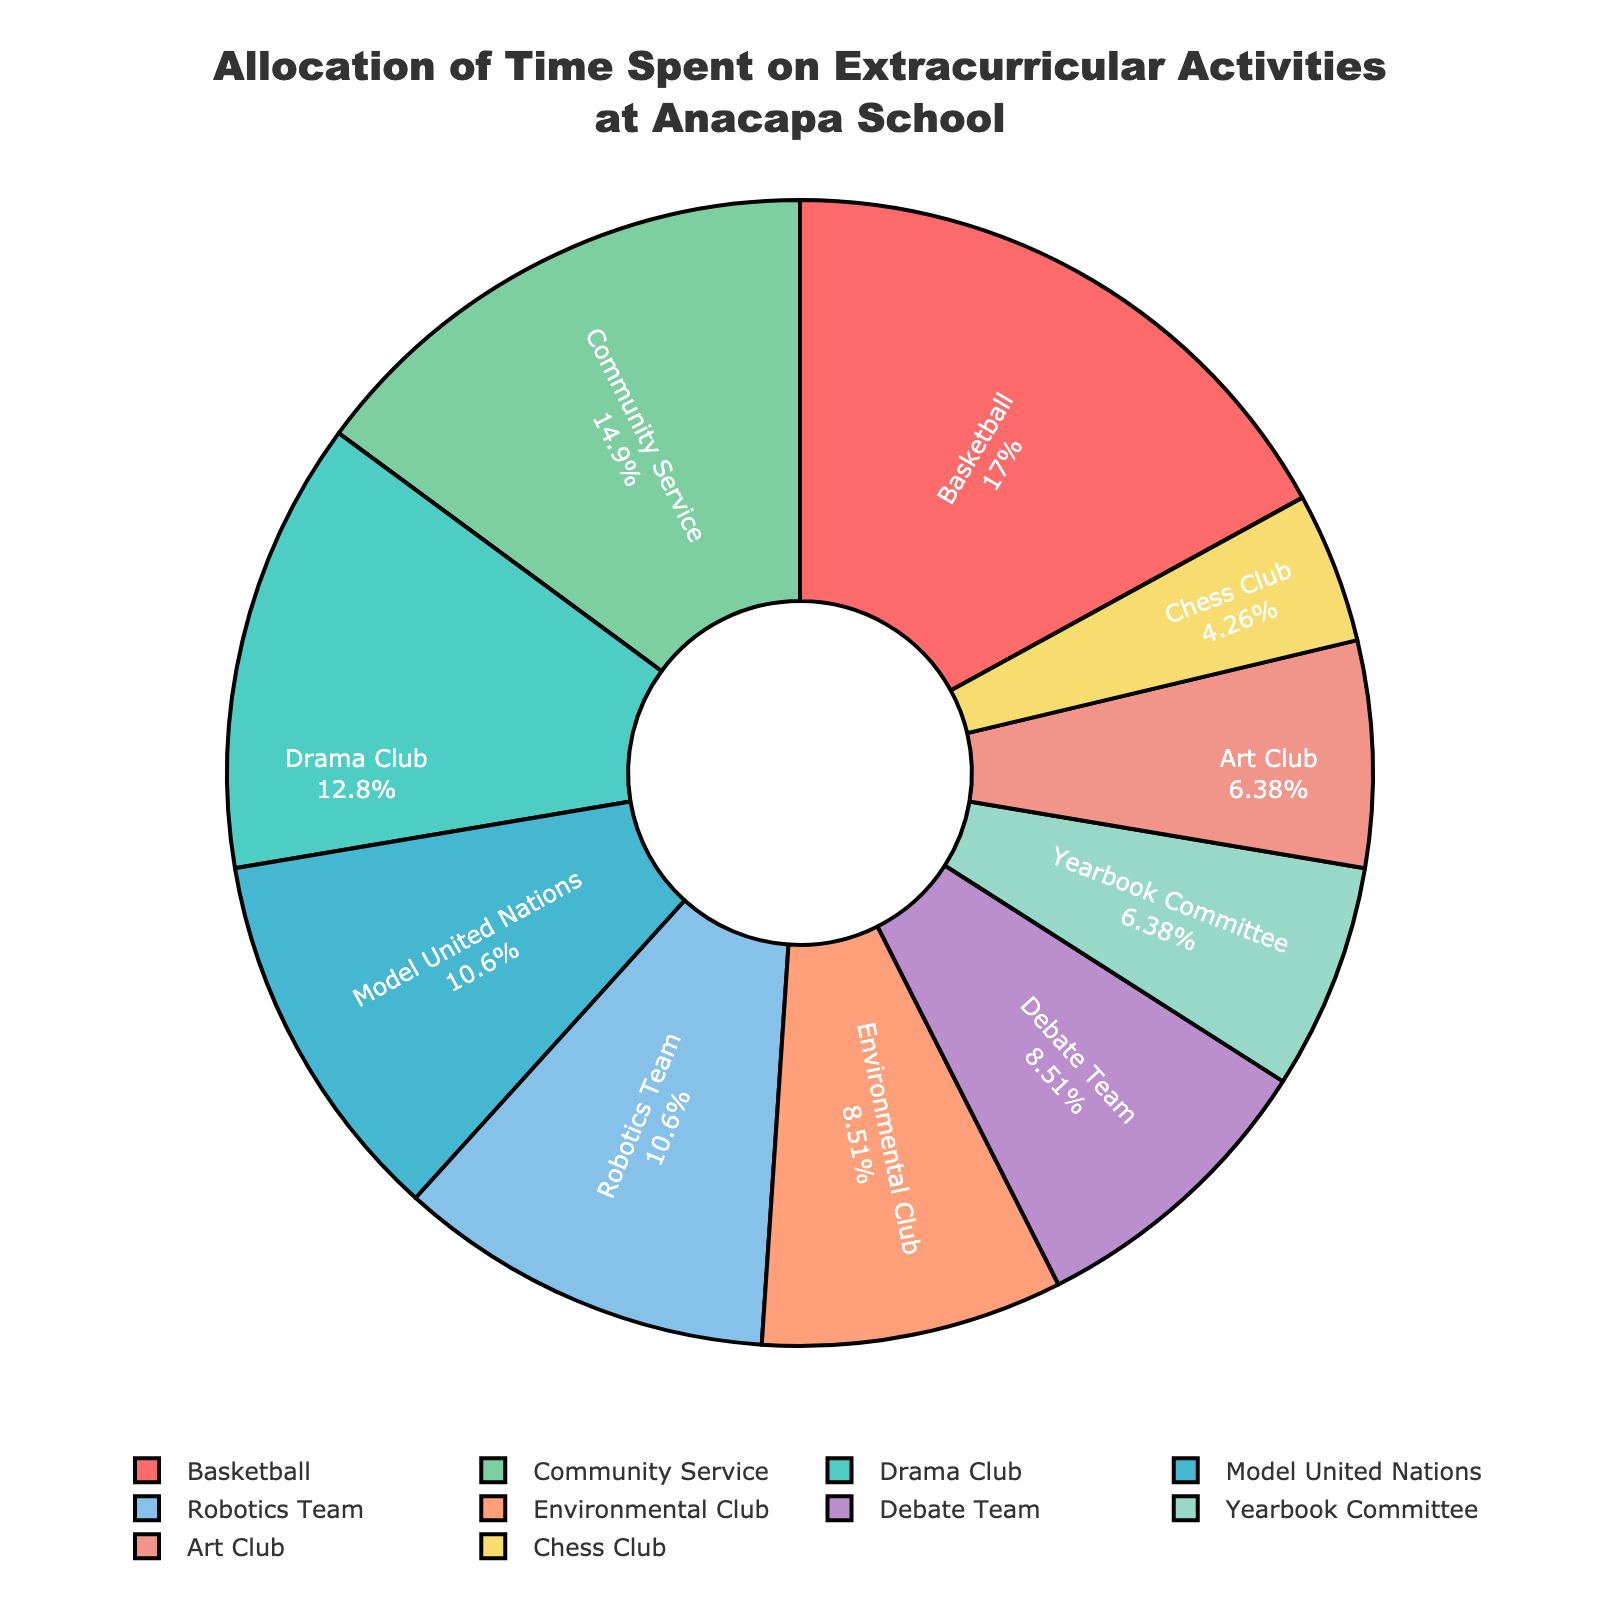What's the activity with the highest number of hours? By looking at the chart, identify the segment with the largest proportion, which corresponds to the activity with the highest number of hours. The basketball segment is the largest, indicating it has the highest number of hours.
Answer: Basketball Which activity has the smallest portion on the pie chart? Locate the segment with the smallest area within the pie chart. The Chess Club segment is the smallest, indicating it has the fewest hours allocated.
Answer: Chess Club How many hours in total are spent on all extracurricular activities? Sum all the hours spent on each activity: 8 (Basketball) + 6 (Drama Club) + 5 (Model United Nations) + 4 (Environmental Club) + 3 (Yearbook Committee) + 2 (Chess Club) + 4 (Debate Team) + 7 (Community Service) + 3 (Art Club) + 5 (Robotics Team) = 47 hours.
Answer: 47 Which activities have an equal amount of hours allocated? Look at the chart and compare segments with equal sizes, which will represent activities with the same amount of hours. Both Environmental Club and Debate Team have equal segments, representing 4 hours each.
Answer: Environmental Club and Debate Team What percentage of the total time is spent on Community Service? Community Service accounts for 7 hours. To find the percentage, use the total time of 47 hours: (7/47) * 100 ≈ 14.89%.
Answer: 14.89% How many hours more are spent on Basketball compared to Chess Club? Subtract the hours spent on Chess Club from the hours spent on Basketball: 8 (Basketball) - 2 (Chess Club) = 6 hours.
Answer: 6 hours Compare the time spent on Drama Club to Art Club. Which is greater and by how many hours? Drama Club has 6 hours, and Art Club has 3 hours. Subtract the smaller value from the larger value: 6 (Drama Club) - 3 (Art Club) = 3 hours more for Drama Club.
Answer: Drama Club, 3 hours What's the average number of hours spent on all the activities? To find the average, divide the total hours by the number of activities: 47 hours / 10 activities = 4.7 hours on average.
Answer: 4.7 hours Which color represents the Yearbook Committee, and how many hours does it indicate? The legend shows Yearbook Committee in light yellow. Locate this color segment on the chart, which corresponds to 3 hours.
Answer: Light yellow, 3 hours Are more hours spent on Robotics Team or Chess Club, and by how much? Robotics Team has 5 hours allocated, whereas Chess Club has 2 hours. The difference is 5 - 2 = 3 hours.
Answer: Robotics Team, 3 hours 